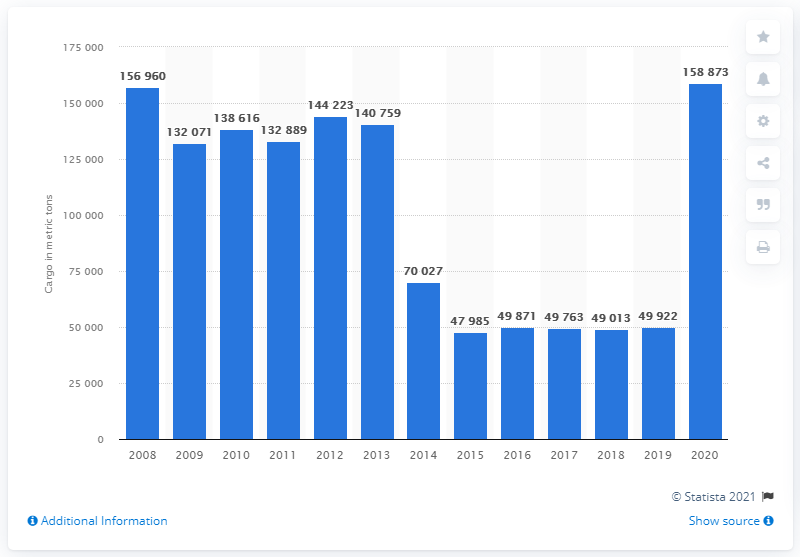Mention a couple of crucial points in this snapshot. In 2020, the total amount of freight transported by British Airways decreased. 